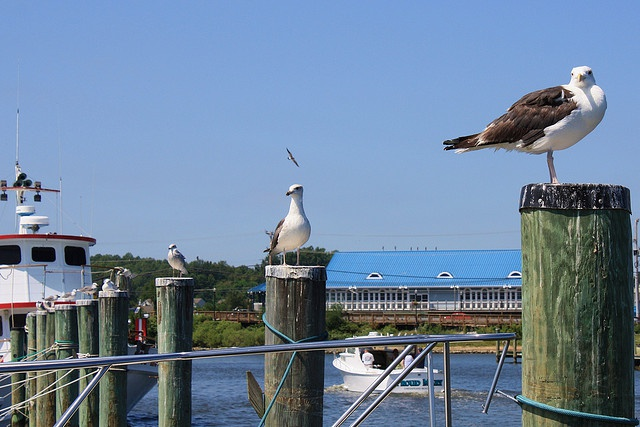Describe the objects in this image and their specific colors. I can see boat in darkgray, lightgray, black, and gray tones, bird in darkgray, black, gray, and lightgray tones, boat in darkgray, lightgray, black, and gray tones, bird in darkgray, lightgray, gray, and tan tones, and bird in darkgray, gray, and black tones in this image. 